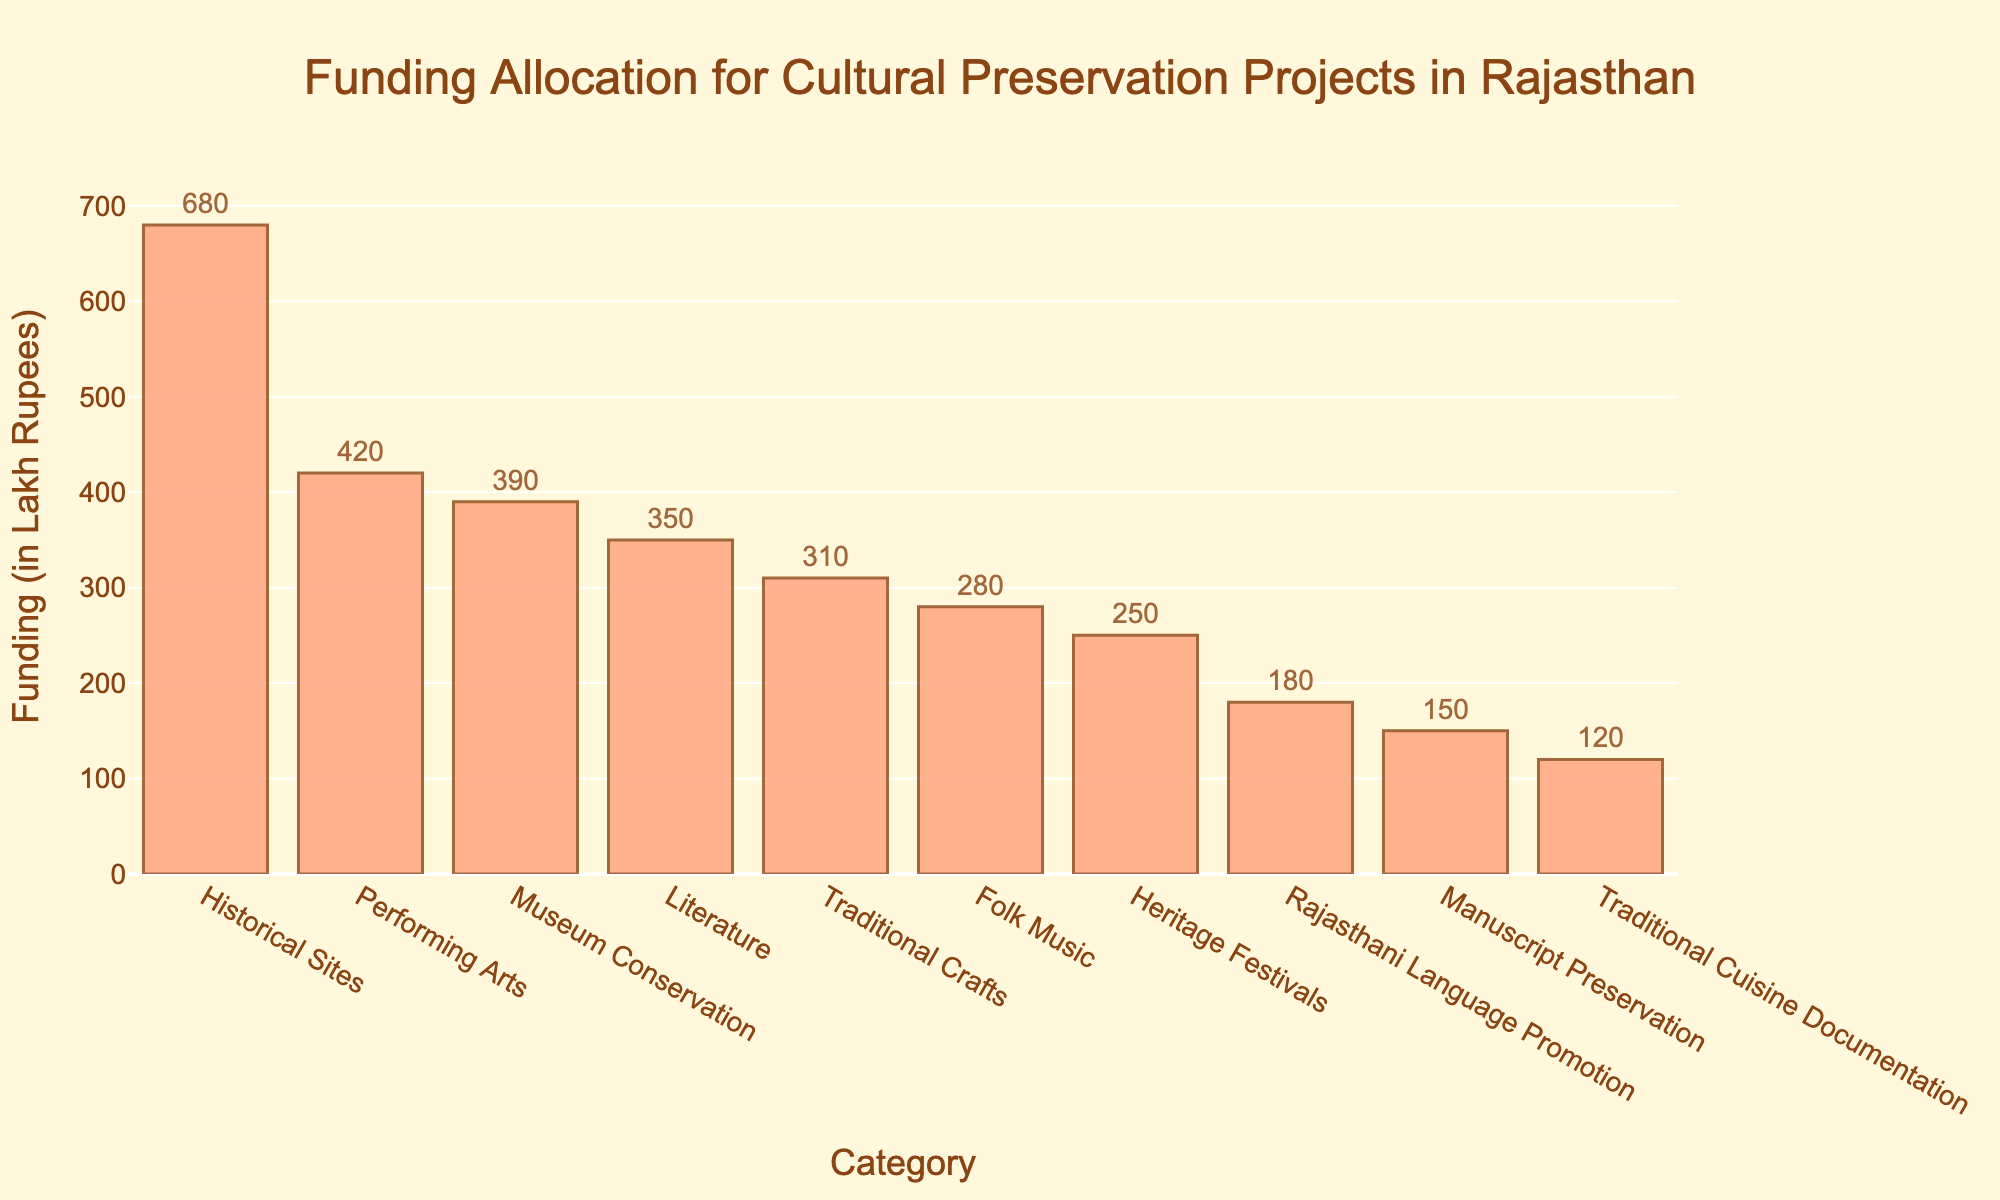What category has the highest funding allocation? The bars in the chart show different categories and their funding allocations. The highest bar corresponds to the Historical Sites category.
Answer: Historical Sites What is the total funding allocated to Literature, Performing Arts, and Historical Sites combined? Sum the funding values for Literature (350), Performing Arts (420), and Historical Sites (680). The total is 350 + 420 + 680 = 1450 Lakh Rupees.
Answer: 1450 Lakh Rupees Which category has the lowest funding allocation? Look for the shortest bar in the chart, which corresponds to the Traditional Cuisine Documentation category.
Answer: Traditional Cuisine Documentation How much more funding does Performing Arts receive than Folk Music? Subtract the funding for Folk Music (280) from the funding for Performing Arts (420). The difference is 420 - 280 = 140 Lakh Rupees.
Answer: 140 Lakh Rupees What is the average funding allocated across all categories? Sum the funding for all categories and divide by the number of categories. Sum: 350 + 420 + 680 + 280 + 310 + 390 + 180 + 250 + 150 + 120 = 3130. Number of categories: 10. Average is 3130 / 10 = 313 Lakh Rupees.
Answer: 313 Lakh Rupees Which categories receive more than 300 Lakh Rupees in funding? Identify all bars with a height (funding value) greater than 300: Literature (350), Performing Arts (420), Historical Sites (680), Traditional Crafts (310), and Museum Conservation (390).
Answer: Literature, Performing Arts, Historical Sites, Traditional Crafts, Museum Conservation What is the difference in funding between the highest and lowest categories? The highest funding is for Historical Sites (680), and the lowest is for Traditional Cuisine Documentation (120). The difference is 680 - 120 = 560 Lakh Rupees.
Answer: 560 Lakh Rupees How does the funding for Museum Conservation compare to Heritage Festivals? Compare the heights of the bars for Museum Conservation (390) and Heritage Festivals (250). Museum Conservation receives more funding.
Answer: Museum Conservation receives more funding What percentage of the total funding is allocated to Historical Sites? Calculate the total funding sum (3130). The funding for Historical Sites is 680. Percentage = (680 / 3130) * 100 ≈ 21.72%.
Answer: Approximately 21.72% What is the median funding value among all categories? List the funding values in ascending order: 120, 150, 180, 250, 280, 310, 350, 390, 420, 680. The median is the average of the 5th and 6th values: (280 + 310) / 2 = 295 Lakh Rupees.
Answer: 295 Lakh Rupees 